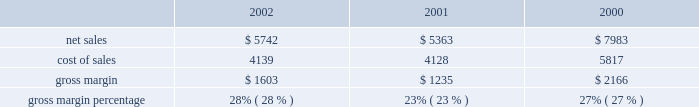In a new business model such as the retail segment is inherently risky , particularly in light of the significant investment involved , the current economic climate , and the fixed nature of a substantial portion of the retail segment's operating expenses .
Results for this segment are dependent upon a number of risks and uncertainties , some of which are discussed below under the heading "factors that may affect future results and financial condition." backlog in the company's experience , the actual amount of product backlog at any particular time is not a meaningful indication of its future business prospects .
In particular , backlog often increases in anticipation of or immediately following new product introductions because of over- ordering by dealers anticipating shortages .
Backlog often is reduced once dealers and customers believe they can obtain sufficient supply .
Because of the foregoing , backlog cannot be considered a reliable indicator of the company's ability to achieve any particular level of revenue or financial performance .
Further information regarding the company's backlog may be found below under the heading "factors that may affect future results and financial condition." gross margin gross margin for the three fiscal years ended september 28 , 2002 are as follows ( in millions , except gross margin percentages ) : gross margin increased to 28% ( 28 % ) of net sales in 2002 from 23% ( 23 % ) in 2001 .
As discussed below , gross margin in 2001 was unusually low resulting from negative gross margin of 2% ( 2 % ) experienced in the first quarter of 2001 .
As a percentage of net sales , the company's quarterly gross margins declined during fiscal 2002 from 31% ( 31 % ) in the first quarter down to 26% ( 26 % ) in the fourth quarter .
This decline resulted from several factors including a rise in component costs as the year progressed and aggressive pricing by the company across its products lines instituted as a result of continued pricing pressures in the personal computer industry .
The company anticipates that its gross margin and the gross margin of the overall personal computer industry will remain under pressure throughout fiscal 2003 in light of weak economic conditions , flat demand for personal computers in general , and the resulting pressure on prices .
The foregoing statements regarding anticipated gross margin in 2003 and the general demand for personal computers during 2003 are forward- looking .
Gross margin could differ from anticipated levels because of several factors , including certain of those set forth below in the subsection entitled "factors that may affect future results and financial condition." there can be no assurance that current gross margins will be maintained , targeted gross margin levels will be achieved , or current margins on existing individual products will be maintained .
In general , gross margins and margins on individual products will remain under significant downward pressure due to a variety of factors , including continued industry wide global pricing pressures , increased competition , compressed product life cycles , potential increases in the cost and availability of raw material and outside manufacturing services , and potential changes to the company's product mix , including higher unit sales of consumer products with lower average selling prices and lower gross margins .
In response to these downward pressures , the company expects it will continue to take pricing actions with respect to its products .
Gross margins could also be affected by the company's ability to effectively manage quality problems and warranty costs and to stimulate demand for certain of its products .
The company's operating strategy and pricing take into account anticipated changes in foreign currency exchange rates over time ; however , the company's results of operations can be significantly affected in the short-term by fluctuations in exchange rates .
The company orders components for its products and builds inventory in advance of product shipments .
Because the company's markets are volatile and subject to rapid technology and price changes , there is a risk the company will forecast incorrectly and produce or order from third parties excess or insufficient inventories of particular products or components .
The company's operating results and financial condition have been in the past and may in the future be materially adversely affected by the company's ability to manage its inventory levels and outstanding purchase commitments and to respond to short-term shifts in customer demand patterns .
Gross margin declined to 23% ( 23 % ) of net sales in 2001 from 27% ( 27 % ) in 2000 .
This decline resulted primarily from gross margin of negative 2% ( 2 % ) experienced during the first quarter of 2001 compared to 26% ( 26 % ) gross margin for the same quarter in 2000 .
In addition to lower than normal net .

What was the lowest gross margin percentage? 
Computations: table_min(gross margin percentage, none)
Answer: 0.23. In a new business model such as the retail segment is inherently risky , particularly in light of the significant investment involved , the current economic climate , and the fixed nature of a substantial portion of the retail segment's operating expenses .
Results for this segment are dependent upon a number of risks and uncertainties , some of which are discussed below under the heading "factors that may affect future results and financial condition." backlog in the company's experience , the actual amount of product backlog at any particular time is not a meaningful indication of its future business prospects .
In particular , backlog often increases in anticipation of or immediately following new product introductions because of over- ordering by dealers anticipating shortages .
Backlog often is reduced once dealers and customers believe they can obtain sufficient supply .
Because of the foregoing , backlog cannot be considered a reliable indicator of the company's ability to achieve any particular level of revenue or financial performance .
Further information regarding the company's backlog may be found below under the heading "factors that may affect future results and financial condition." gross margin gross margin for the three fiscal years ended september 28 , 2002 are as follows ( in millions , except gross margin percentages ) : gross margin increased to 28% ( 28 % ) of net sales in 2002 from 23% ( 23 % ) in 2001 .
As discussed below , gross margin in 2001 was unusually low resulting from negative gross margin of 2% ( 2 % ) experienced in the first quarter of 2001 .
As a percentage of net sales , the company's quarterly gross margins declined during fiscal 2002 from 31% ( 31 % ) in the first quarter down to 26% ( 26 % ) in the fourth quarter .
This decline resulted from several factors including a rise in component costs as the year progressed and aggressive pricing by the company across its products lines instituted as a result of continued pricing pressures in the personal computer industry .
The company anticipates that its gross margin and the gross margin of the overall personal computer industry will remain under pressure throughout fiscal 2003 in light of weak economic conditions , flat demand for personal computers in general , and the resulting pressure on prices .
The foregoing statements regarding anticipated gross margin in 2003 and the general demand for personal computers during 2003 are forward- looking .
Gross margin could differ from anticipated levels because of several factors , including certain of those set forth below in the subsection entitled "factors that may affect future results and financial condition." there can be no assurance that current gross margins will be maintained , targeted gross margin levels will be achieved , or current margins on existing individual products will be maintained .
In general , gross margins and margins on individual products will remain under significant downward pressure due to a variety of factors , including continued industry wide global pricing pressures , increased competition , compressed product life cycles , potential increases in the cost and availability of raw material and outside manufacturing services , and potential changes to the company's product mix , including higher unit sales of consumer products with lower average selling prices and lower gross margins .
In response to these downward pressures , the company expects it will continue to take pricing actions with respect to its products .
Gross margins could also be affected by the company's ability to effectively manage quality problems and warranty costs and to stimulate demand for certain of its products .
The company's operating strategy and pricing take into account anticipated changes in foreign currency exchange rates over time ; however , the company's results of operations can be significantly affected in the short-term by fluctuations in exchange rates .
The company orders components for its products and builds inventory in advance of product shipments .
Because the company's markets are volatile and subject to rapid technology and price changes , there is a risk the company will forecast incorrectly and produce or order from third parties excess or insufficient inventories of particular products or components .
The company's operating results and financial condition have been in the past and may in the future be materially adversely affected by the company's ability to manage its inventory levels and outstanding purchase commitments and to respond to short-term shifts in customer demand patterns .
Gross margin declined to 23% ( 23 % ) of net sales in 2001 from 27% ( 27 % ) in 2000 .
This decline resulted primarily from gross margin of negative 2% ( 2 % ) experienced during the first quarter of 2001 compared to 26% ( 26 % ) gross margin for the same quarter in 2000 .
In addition to lower than normal net .

What was the highest gross margin percentage? 
Computations: table_max(gross margin percentage, none)
Answer: 0.28. 